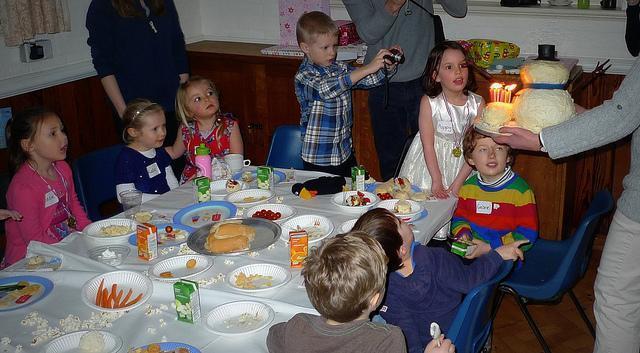Evaluate: Does the caption "The cake is on the dining table." match the image?
Answer yes or no. No. 